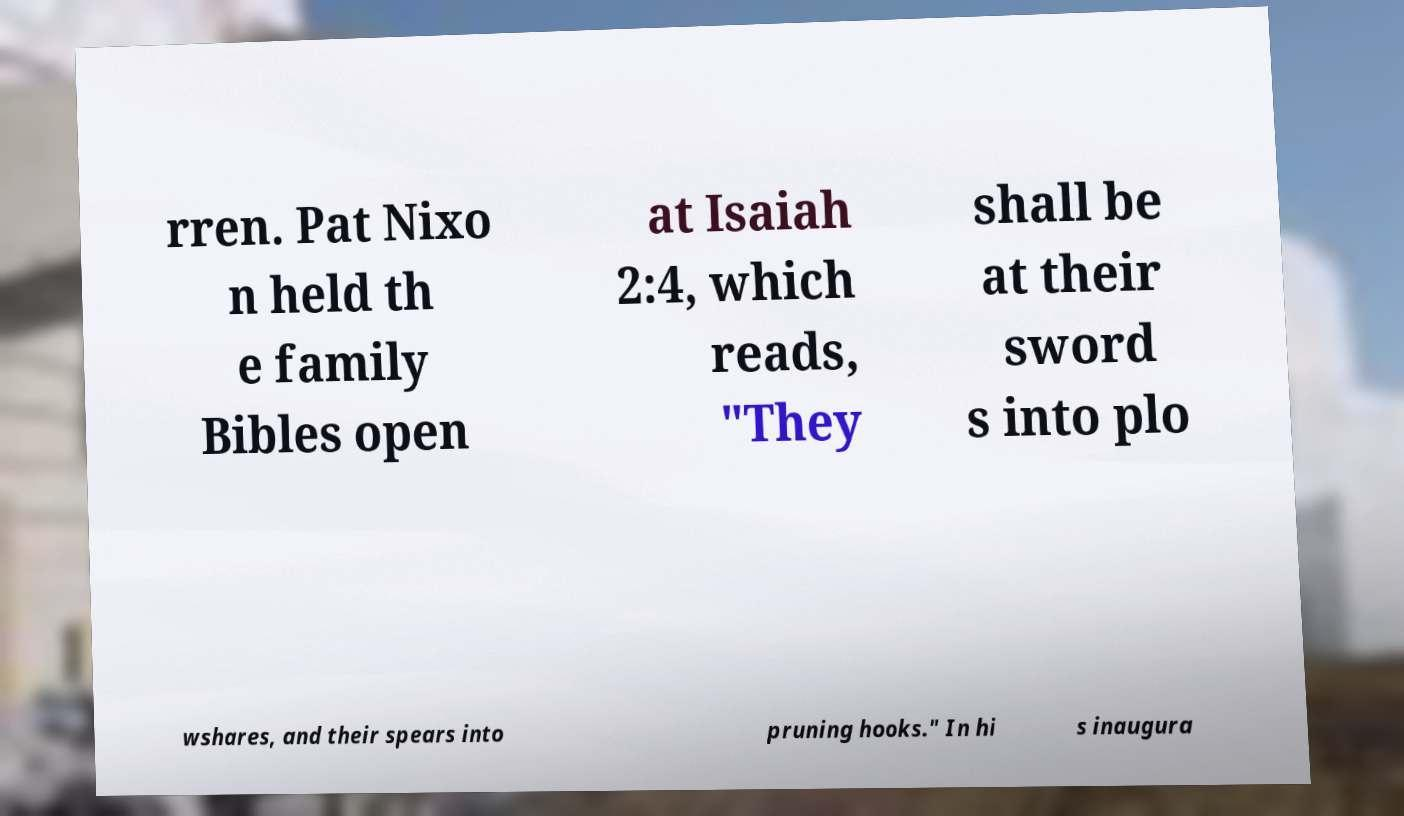I need the written content from this picture converted into text. Can you do that? rren. Pat Nixo n held th e family Bibles open at Isaiah 2:4, which reads, "They shall be at their sword s into plo wshares, and their spears into pruning hooks." In hi s inaugura 